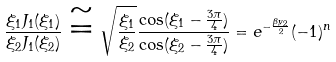Convert formula to latex. <formula><loc_0><loc_0><loc_500><loc_500>\frac { \xi _ { 1 } J _ { 1 } ( \xi _ { 1 } ) } { \xi _ { 2 } J _ { 1 } ( \xi _ { 2 } ) } \cong \sqrt { \frac { \xi _ { 1 } } { \xi _ { 2 } } } \frac { \cos ( \xi _ { 1 } - \frac { 3 \pi } { 4 } ) } { \cos ( \xi _ { 2 } - \frac { 3 \pi } { 4 } ) } = e ^ { - \frac { \beta y _ { 2 } } { 2 } } ( - 1 ) ^ { n }</formula> 